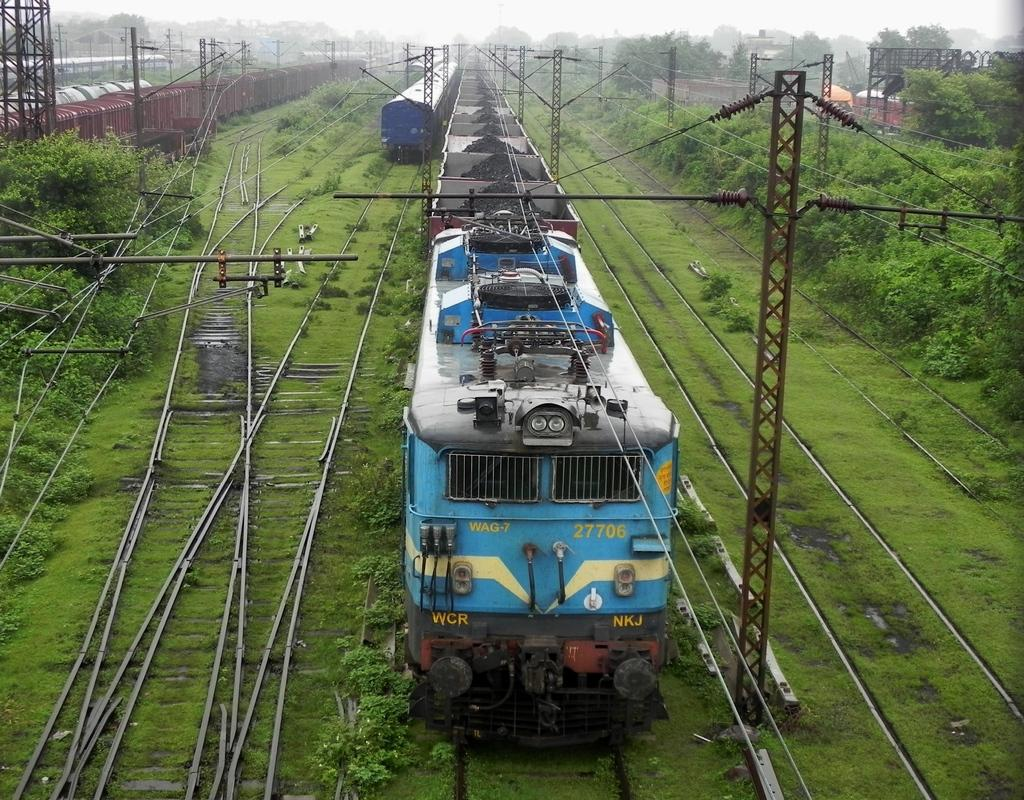What type of vehicles can be seen on the track in the image? There are trains on the track in the image. What material is used for the frames in the image? The frames in the image are made of metal. What are the poles with wires used for in the image? The poles with wires are likely used for transmitting electricity or communication signals. What type of vegetation is present in the image? There is grass, plants, and a group of trees in the image. What is visible in the sky in the image? The sky is visible in the image, and it looks cloudy. What is the texture of the patch on the minute hand of the clock in the image? There is no clock or minute hand present in the image; it features trains, metal frames, poles with wires, grass, plants, trees, and a cloudy sky. 